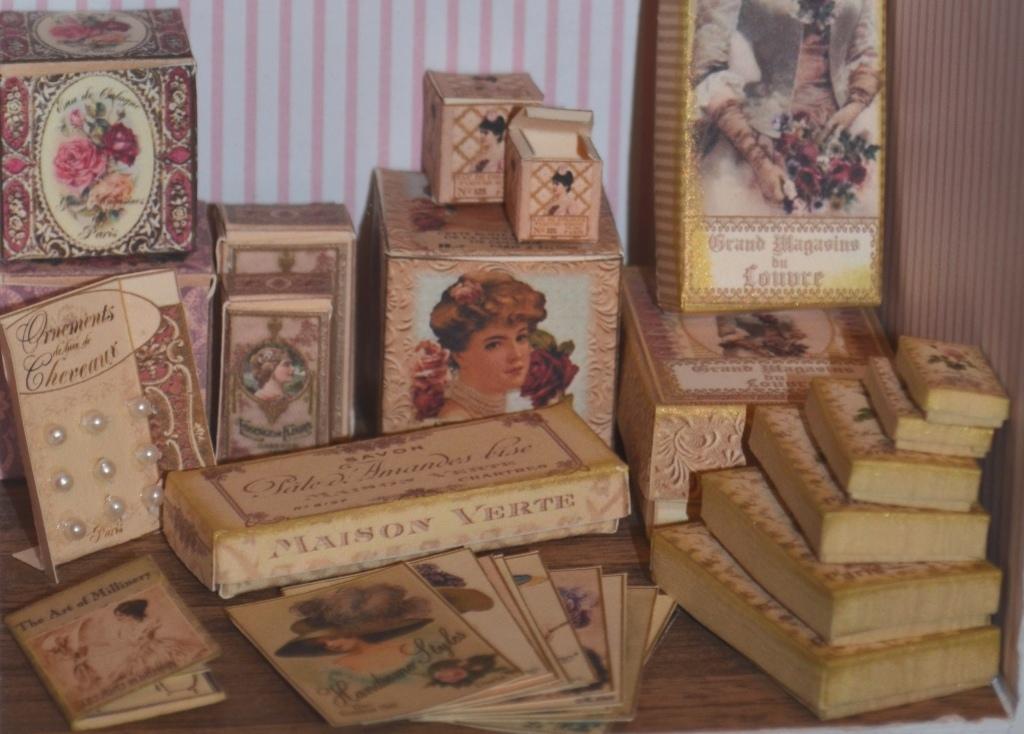Can you describe this image briefly? Here I can see a book, cards and many boxes are placed on a wooden surface. On the the right side there is a cloth. In the background there is a wall. 